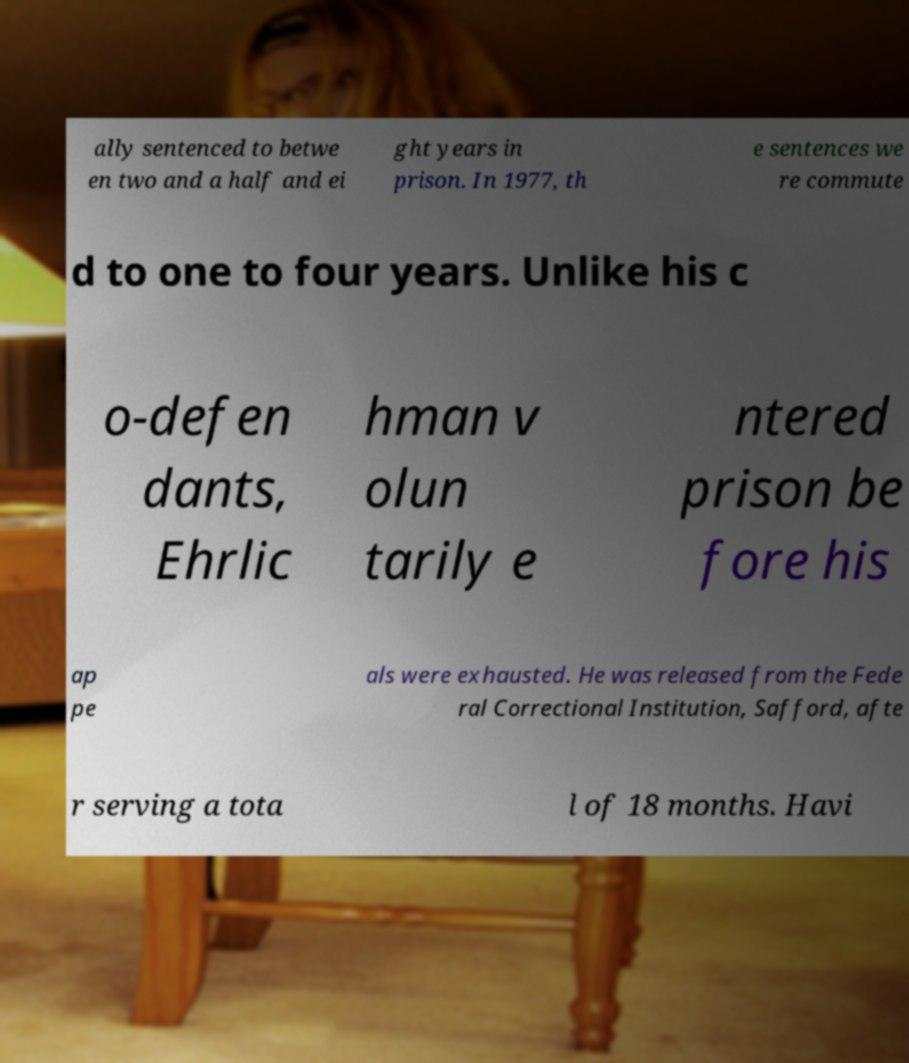Could you extract and type out the text from this image? ally sentenced to betwe en two and a half and ei ght years in prison. In 1977, th e sentences we re commute d to one to four years. Unlike his c o-defen dants, Ehrlic hman v olun tarily e ntered prison be fore his ap pe als were exhausted. He was released from the Fede ral Correctional Institution, Safford, afte r serving a tota l of 18 months. Havi 